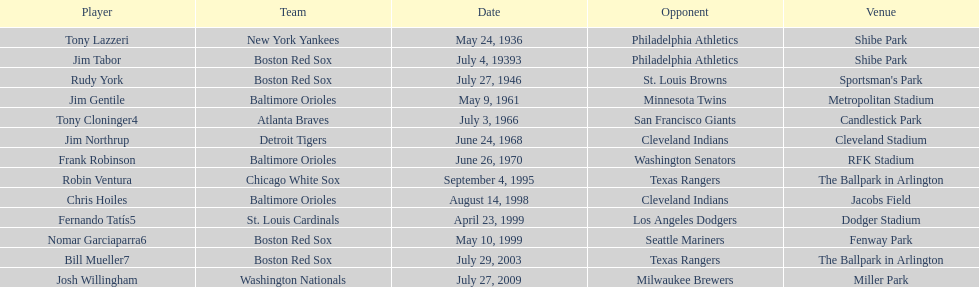Who was the player that achieved this in 1999 and was a part of the boston red sox team? Nomar Garciaparra. 